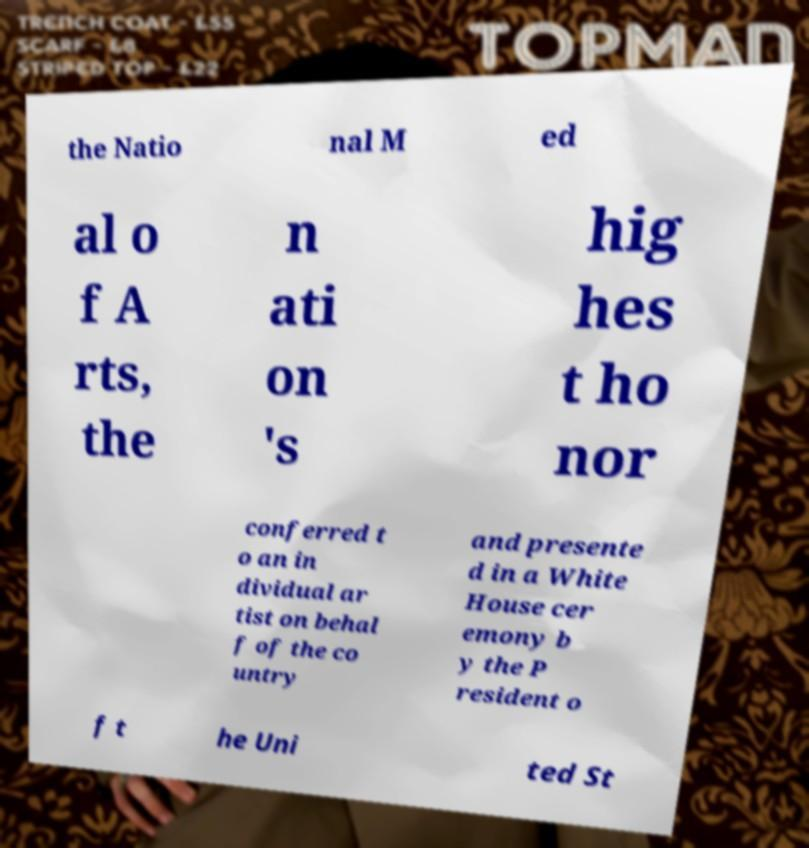Could you extract and type out the text from this image? the Natio nal M ed al o f A rts, the n ati on 's hig hes t ho nor conferred t o an in dividual ar tist on behal f of the co untry and presente d in a White House cer emony b y the P resident o f t he Uni ted St 